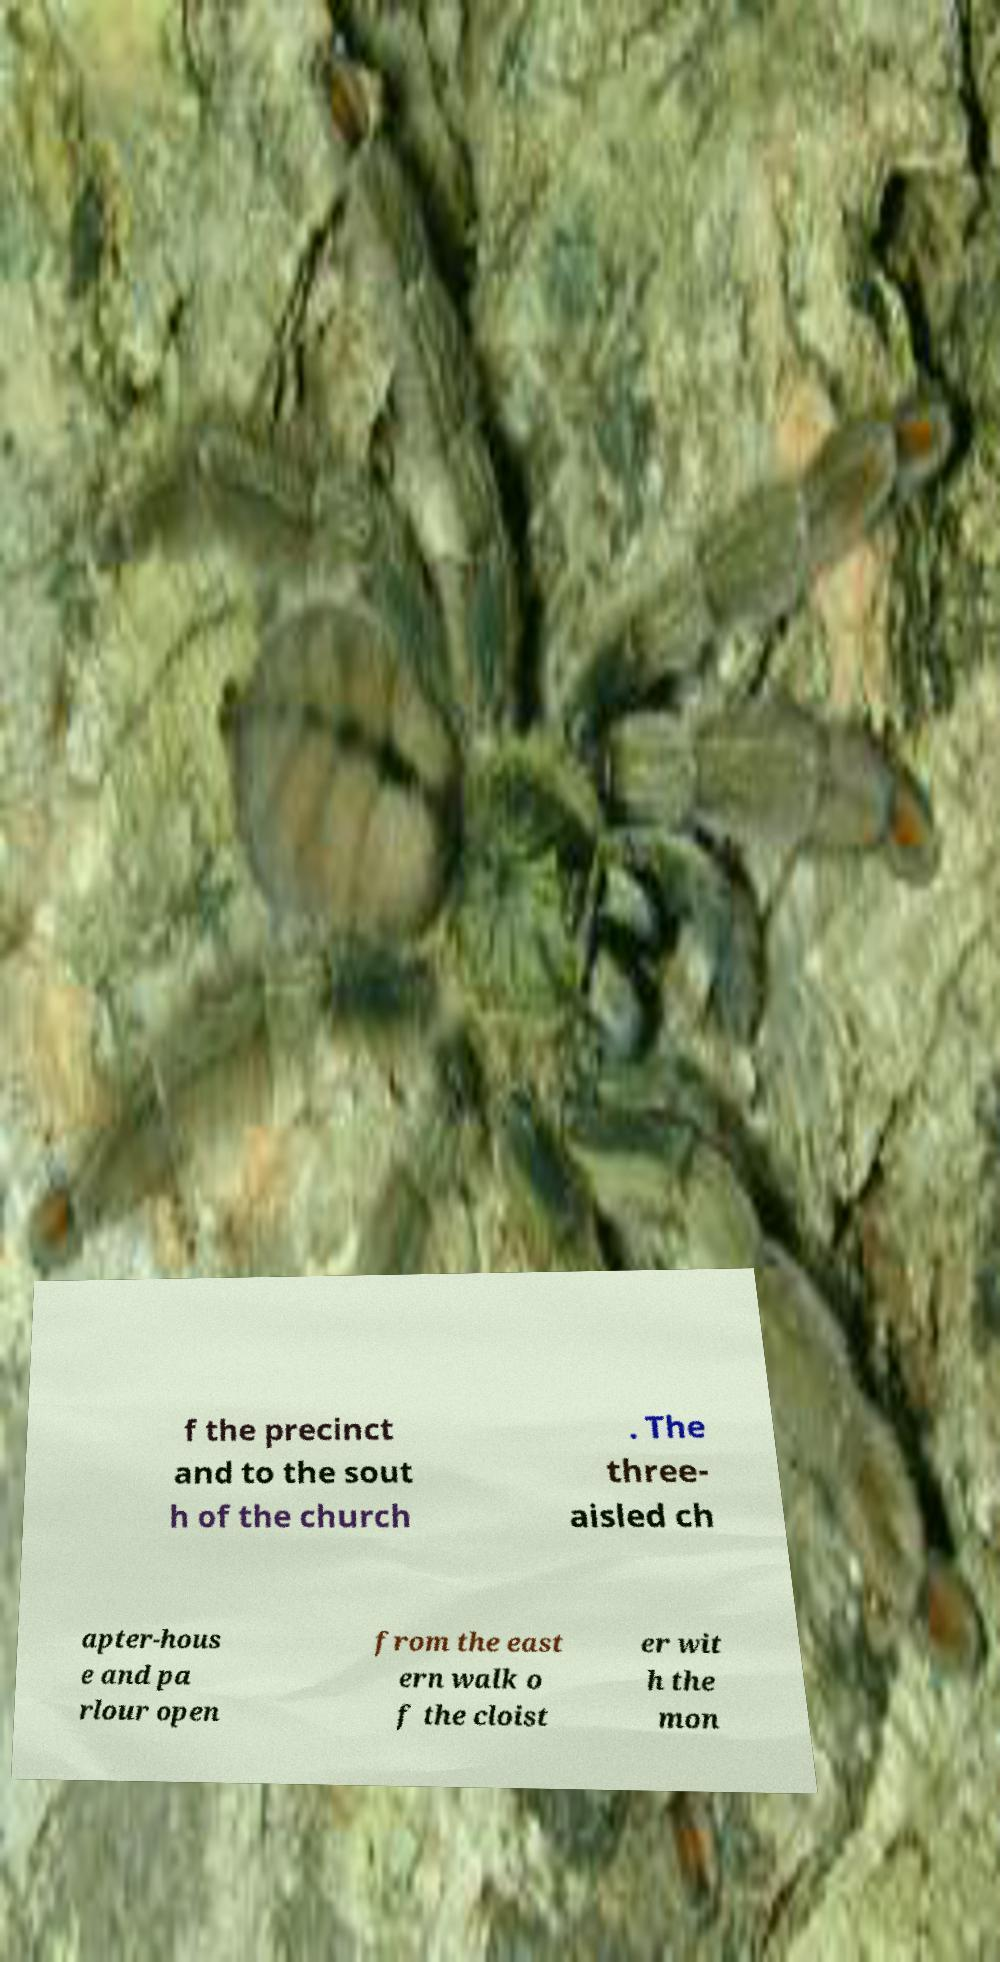What messages or text are displayed in this image? I need them in a readable, typed format. f the precinct and to the sout h of the church . The three- aisled ch apter-hous e and pa rlour open from the east ern walk o f the cloist er wit h the mon 